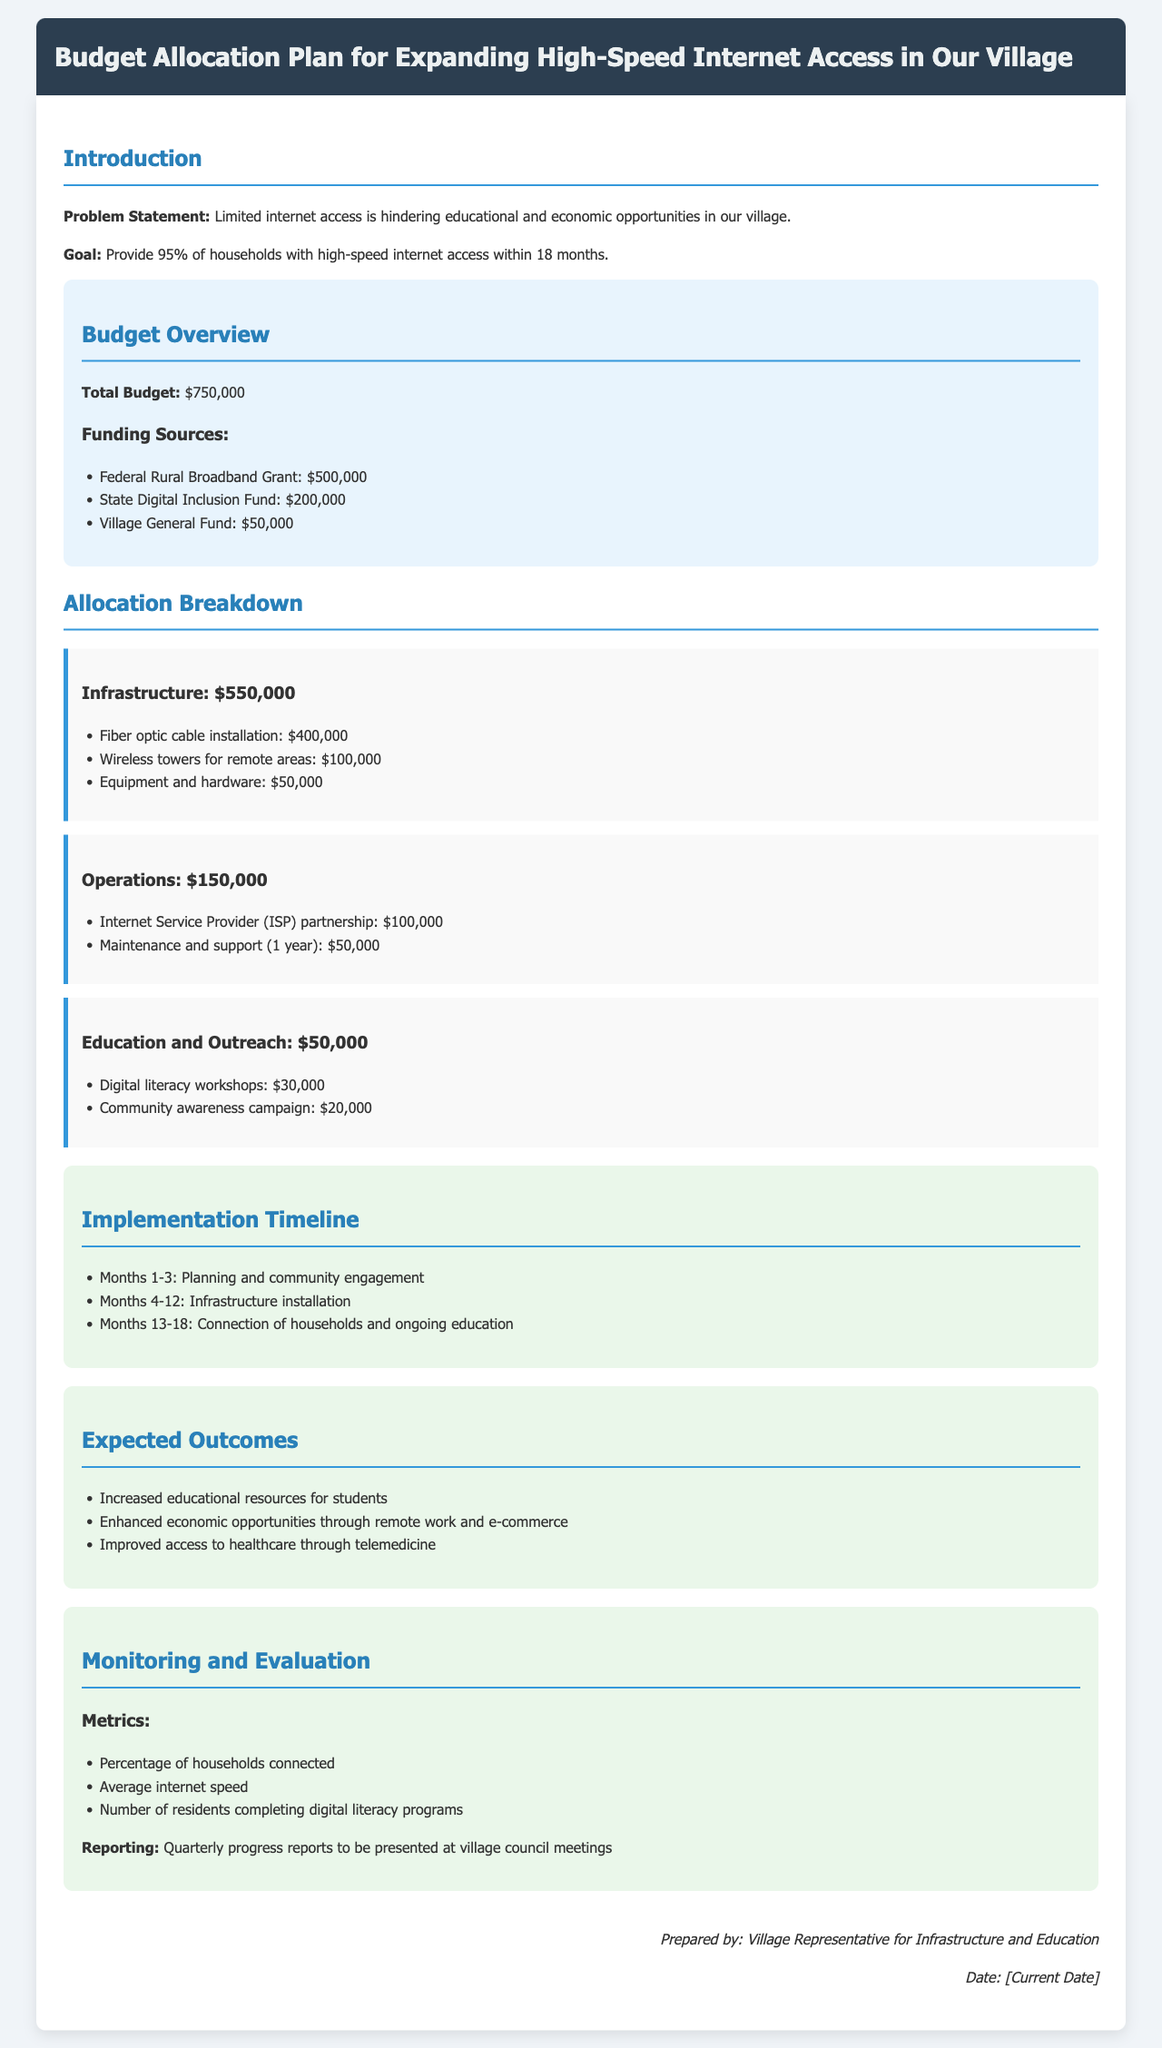What is the total budget? The total budget is explicitly stated in the document under the budget overview section.
Answer: $750,000 What is the goal of the internet expansion project? The goal is defined clearly in the introduction section of the document.
Answer: Provide 95% of households with high-speed internet access within 18 months How much is allocated for infrastructure? The allocation breakdown for infrastructure is detailed in the respective section.
Answer: $550,000 What is the funding source amount from the Federal Rural Broadband Grant? The amount from this funding source is specified in the funding sources list.
Answer: $500,000 What percentage of households connected is a monitoring metric? This is one of the key metrics mentioned under monitoring and evaluation.
Answer: Percentage of households connected What activities occur in Months 4-12? The implementation timeline outlines what happens during these specific months.
Answer: Infrastructure installation How much is dedicated to digital literacy workshops? The document specifies the allocation for educational outreach under the education and outreach section.
Answer: $30,000 What are the expected outcomes of the project? Expected outcomes are listed in a dedicated section of the document.
Answer: Increased educational resources for students What is the reporting frequency for progress reports? The monitoring section discusses how often progress is reported to the village council.
Answer: Quarterly How much is allocated for maintenance and support? This allocation is mentioned in the operations section of the document.
Answer: $50,000 